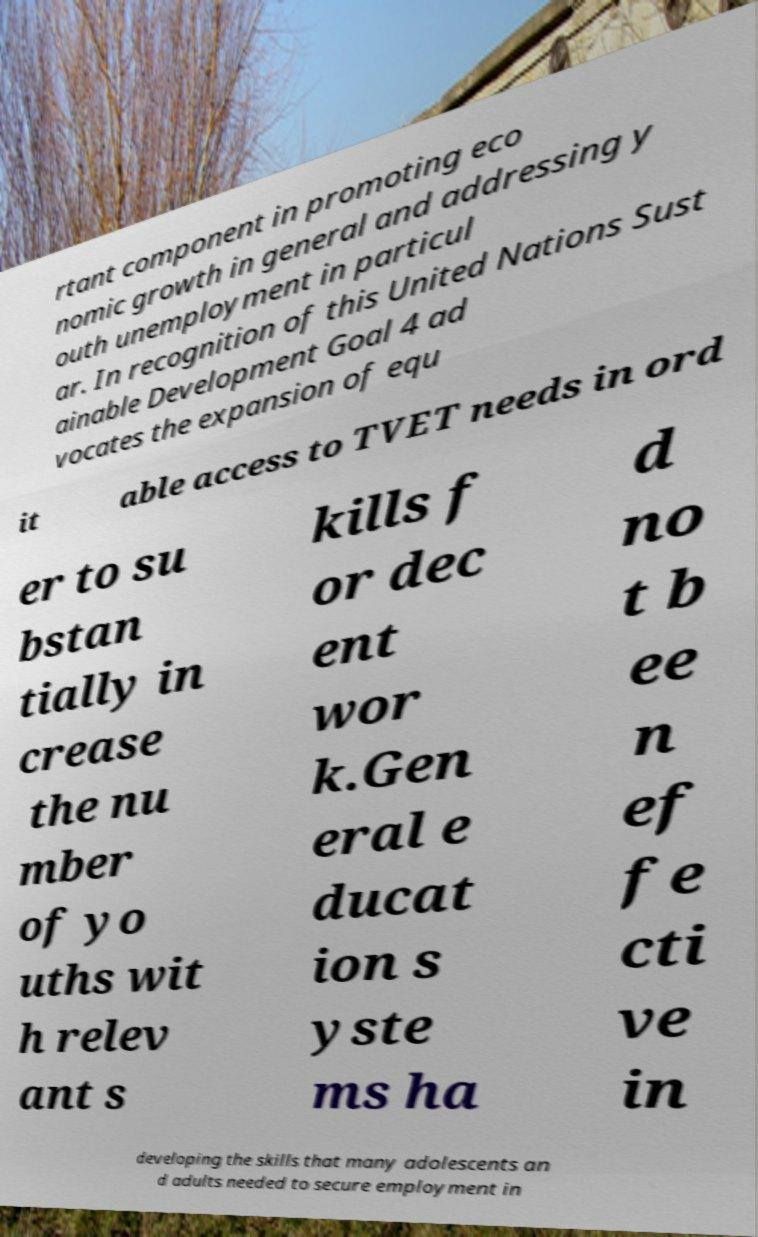There's text embedded in this image that I need extracted. Can you transcribe it verbatim? rtant component in promoting eco nomic growth in general and addressing y outh unemployment in particul ar. In recognition of this United Nations Sust ainable Development Goal 4 ad vocates the expansion of equ it able access to TVET needs in ord er to su bstan tially in crease the nu mber of yo uths wit h relev ant s kills f or dec ent wor k.Gen eral e ducat ion s yste ms ha d no t b ee n ef fe cti ve in developing the skills that many adolescents an d adults needed to secure employment in 